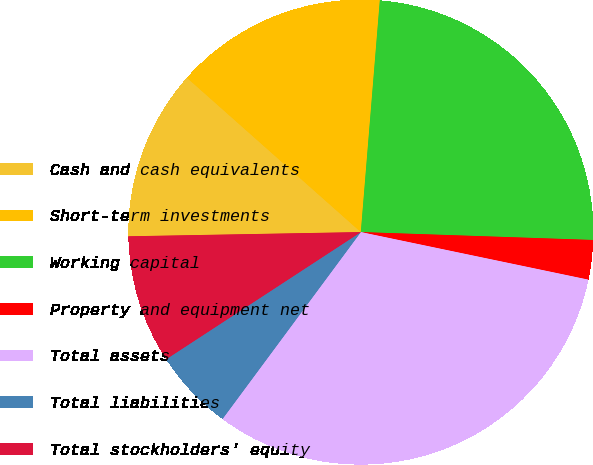Convert chart. <chart><loc_0><loc_0><loc_500><loc_500><pie_chart><fcel>Cash and cash equivalents<fcel>Short-term investments<fcel>Working capital<fcel>Property and equipment net<fcel>Total assets<fcel>Total liabilities<fcel>Total stockholders' equity<nl><fcel>11.84%<fcel>14.75%<fcel>24.24%<fcel>2.74%<fcel>31.86%<fcel>5.65%<fcel>8.92%<nl></chart> 